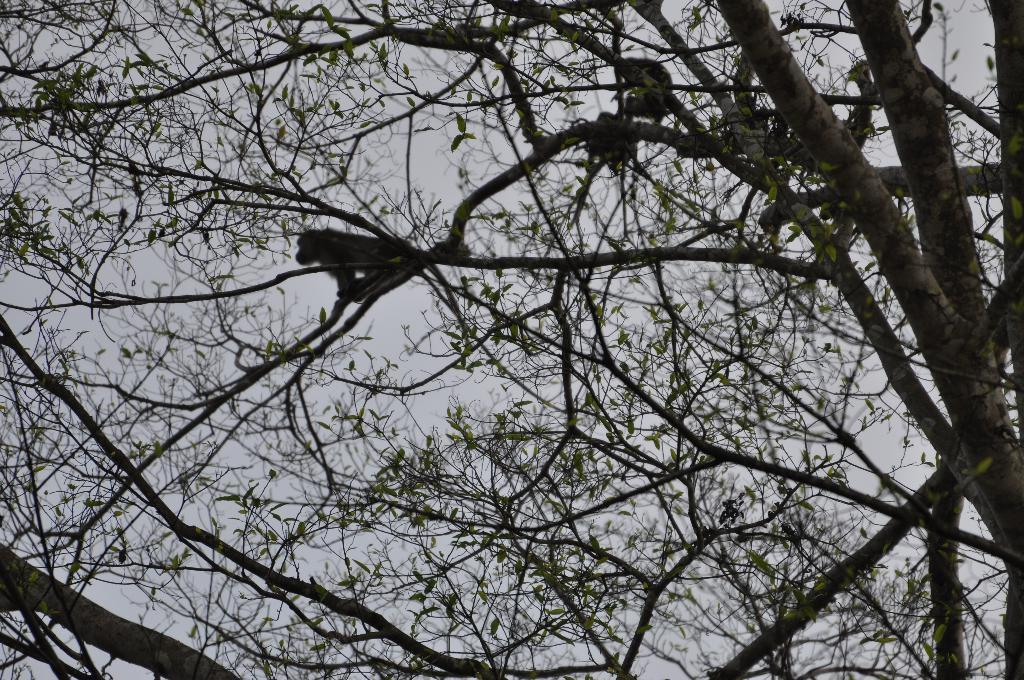What animals are present in the image? There are monkeys in the image. Where are the monkeys located? The monkeys are on trees. What is visible at the top of the image? The sky is visible at the top of the image. What type of cart can be seen being pushed by the boys in the image? There are no boys or carts present in the image; it features monkeys on trees. 